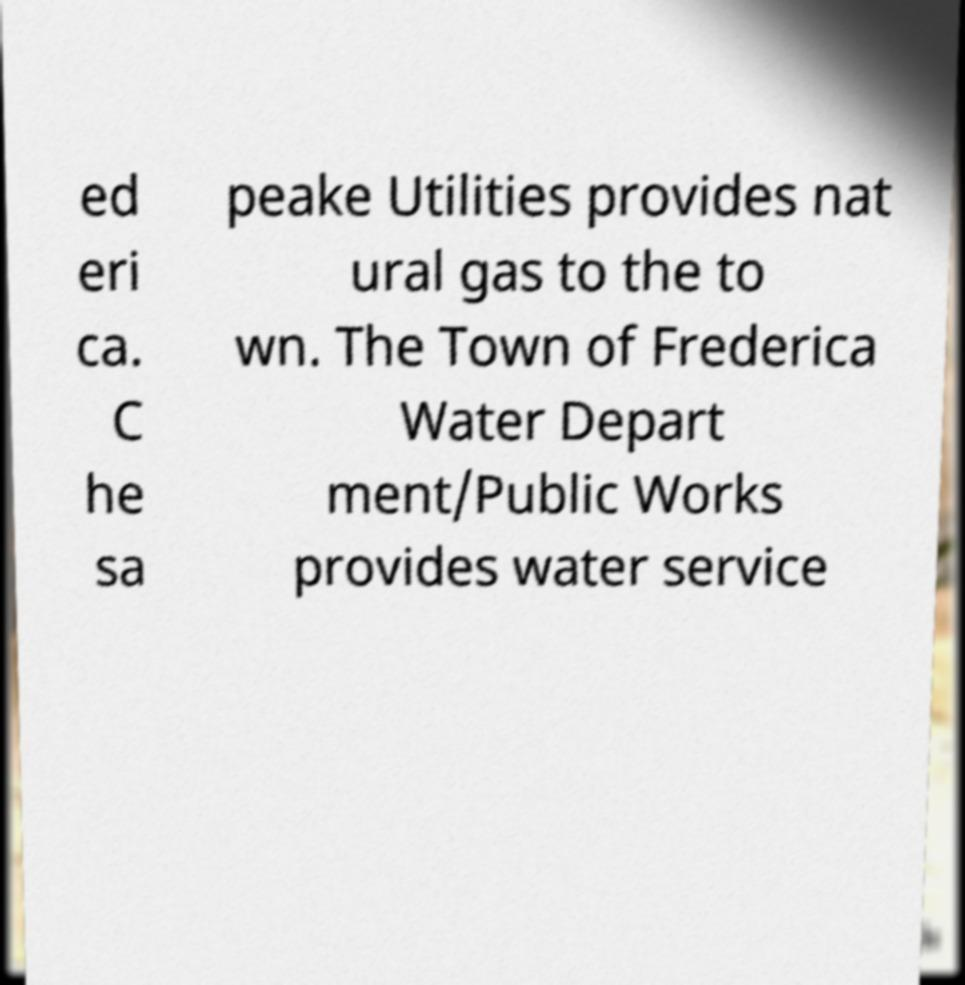I need the written content from this picture converted into text. Can you do that? ed eri ca. C he sa peake Utilities provides nat ural gas to the to wn. The Town of Frederica Water Depart ment/Public Works provides water service 